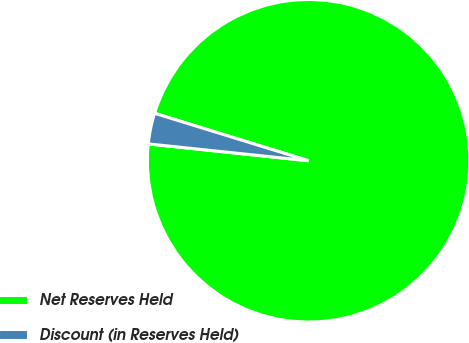<chart> <loc_0><loc_0><loc_500><loc_500><pie_chart><fcel>Net Reserves Held<fcel>Discount (in Reserves Held)<nl><fcel>96.91%<fcel>3.09%<nl></chart> 